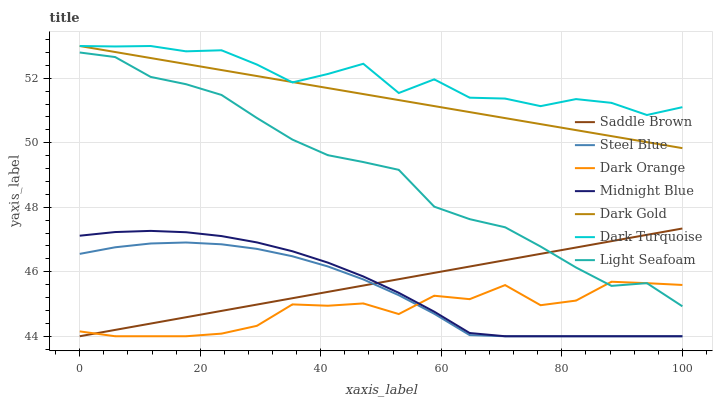Does Dark Orange have the minimum area under the curve?
Answer yes or no. Yes. Does Dark Turquoise have the maximum area under the curve?
Answer yes or no. Yes. Does Midnight Blue have the minimum area under the curve?
Answer yes or no. No. Does Midnight Blue have the maximum area under the curve?
Answer yes or no. No. Is Dark Gold the smoothest?
Answer yes or no. Yes. Is Dark Turquoise the roughest?
Answer yes or no. Yes. Is Midnight Blue the smoothest?
Answer yes or no. No. Is Midnight Blue the roughest?
Answer yes or no. No. Does Dark Orange have the lowest value?
Answer yes or no. Yes. Does Dark Gold have the lowest value?
Answer yes or no. No. Does Dark Turquoise have the highest value?
Answer yes or no. Yes. Does Midnight Blue have the highest value?
Answer yes or no. No. Is Steel Blue less than Light Seafoam?
Answer yes or no. Yes. Is Light Seafoam greater than Steel Blue?
Answer yes or no. Yes. Does Saddle Brown intersect Midnight Blue?
Answer yes or no. Yes. Is Saddle Brown less than Midnight Blue?
Answer yes or no. No. Is Saddle Brown greater than Midnight Blue?
Answer yes or no. No. Does Steel Blue intersect Light Seafoam?
Answer yes or no. No. 